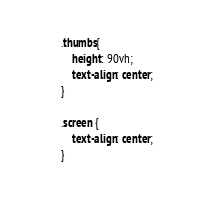<code> <loc_0><loc_0><loc_500><loc_500><_CSS_>.thumbs{
	height: 90vh;
	text-align: center;	
}

.screen {
	text-align: center;	
}</code> 